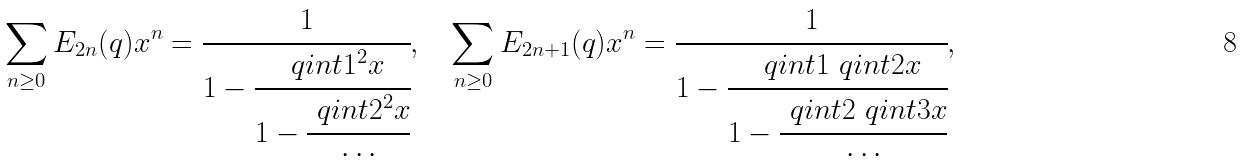Convert formula to latex. <formula><loc_0><loc_0><loc_500><loc_500>\sum _ { n \geq 0 } E _ { 2 n } ( q ) x ^ { n } = \cfrac { 1 } { 1 - \cfrac { \ q i n t { 1 } ^ { 2 } x } { 1 - \cfrac { \ q i n t { 2 } ^ { 2 } x } { \cdots } } } , \quad \sum _ { n \geq 0 } E _ { 2 n + 1 } ( q ) x ^ { n } = \cfrac { 1 } { 1 - \cfrac { \ q i n t { 1 } \ q i n t 2 x } { 1 - \cfrac { \ q i n t { 2 } \ q i n t 3 x } { \cdots } } } ,</formula> 